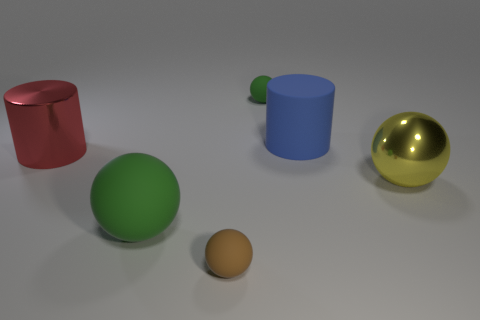Is there a large thing of the same color as the large rubber cylinder?
Give a very brief answer. No. What number of other things are the same shape as the large green thing?
Keep it short and to the point. 3. There is a small thing right of the brown rubber thing; what is its shape?
Your answer should be very brief. Sphere. Do the tiny green thing and the big blue object on the right side of the big green object have the same shape?
Provide a short and direct response. No. There is a thing that is to the right of the tiny green matte thing and behind the red metal thing; what size is it?
Your response must be concise. Large. There is a big object that is both left of the big blue rubber thing and to the right of the red cylinder; what is its color?
Keep it short and to the point. Green. Is there any other thing that has the same material as the brown sphere?
Offer a terse response. Yes. Are there fewer big yellow metal things that are behind the red metallic object than big yellow things left of the tiny brown sphere?
Provide a short and direct response. No. Are there any other things that have the same color as the large rubber cylinder?
Offer a very short reply. No. There is a tiny brown rubber object; what shape is it?
Make the answer very short. Sphere. 